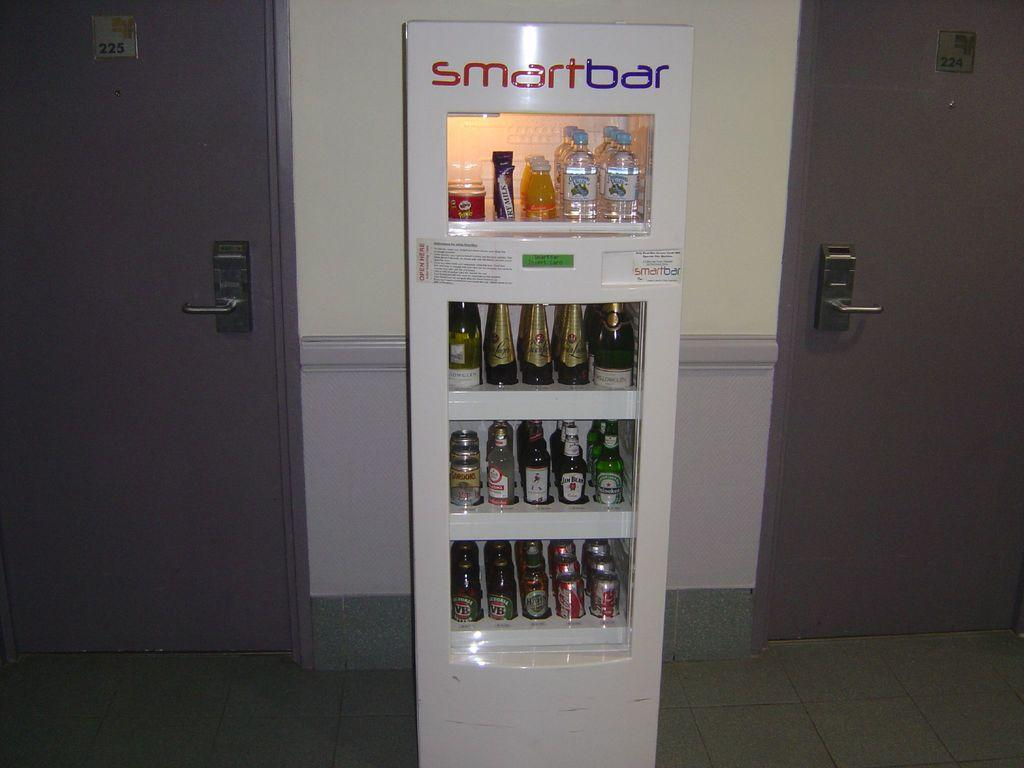<image>
Write a terse but informative summary of the picture. a SMART BAR vending machine with various drinks for sale 